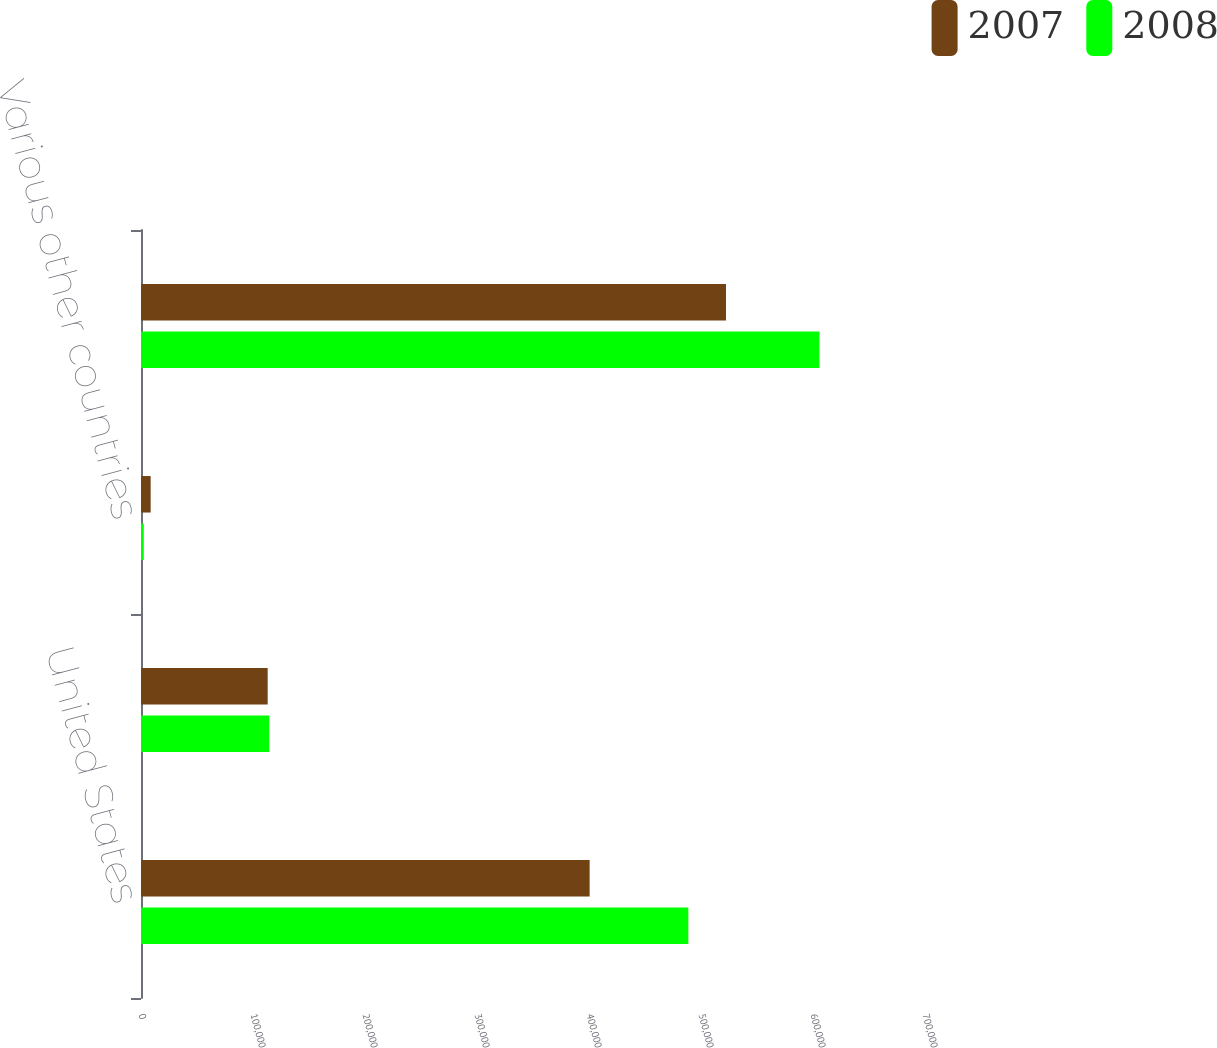Convert chart. <chart><loc_0><loc_0><loc_500><loc_500><stacked_bar_chart><ecel><fcel>United States<fcel>Thailand<fcel>Various other countries<fcel>Total long-lived assets<nl><fcel>2007<fcel>400564<fcel>113117<fcel>8624<fcel>522305<nl><fcel>2008<fcel>488687<fcel>114560<fcel>2475<fcel>605722<nl></chart> 